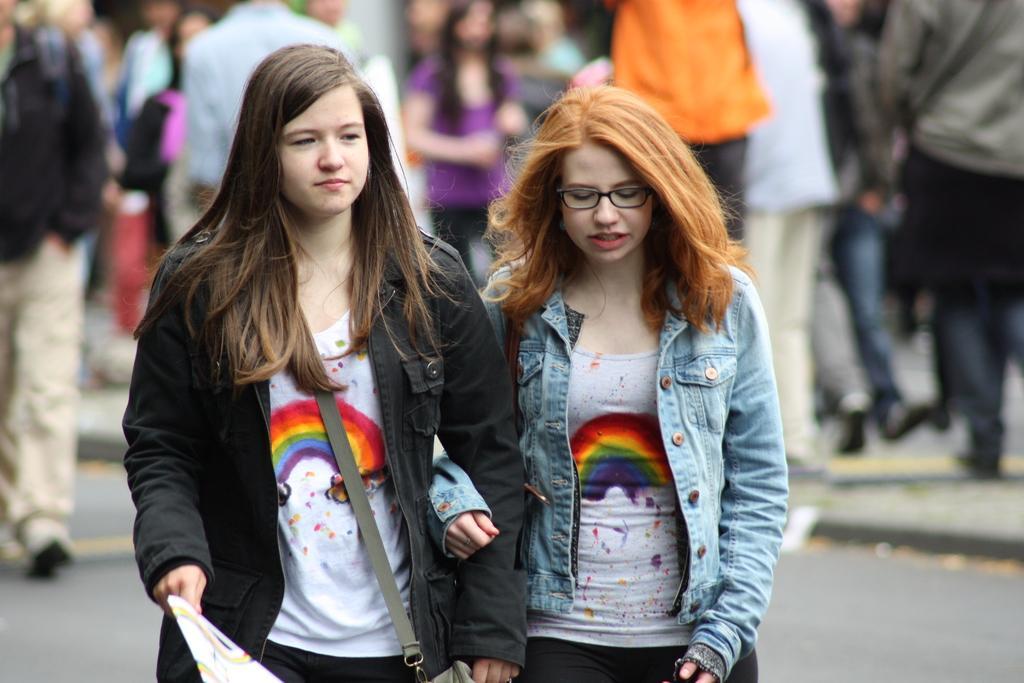How would you summarize this image in a sentence or two? This picture is clicked outside. In the foreground we can see the two women wearing jackets and seems to be walking. In the background we can see the group of people seems to be walking on the ground. 